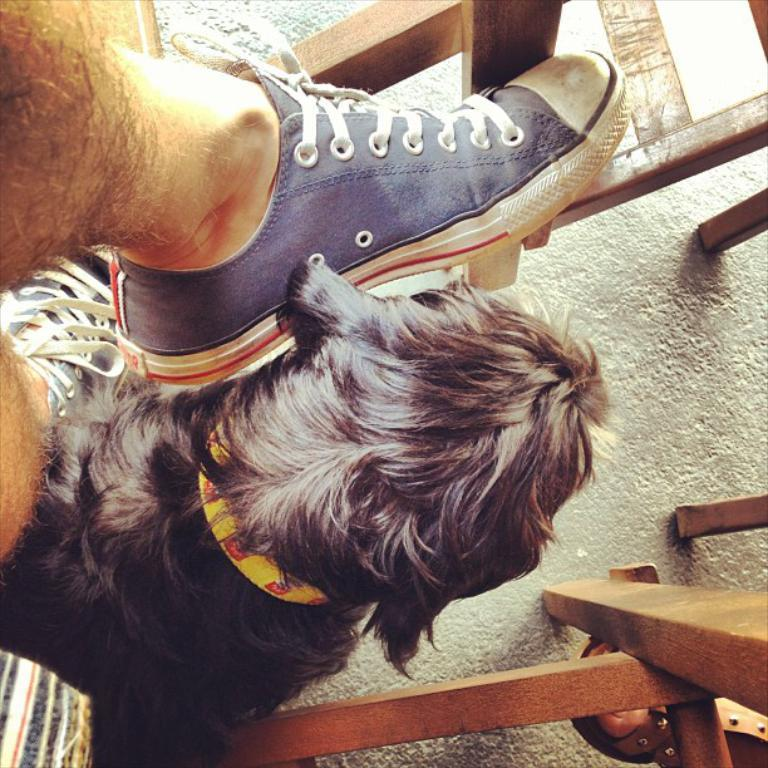What can be seen in the image that belongs to a person? There are legs of persons in the image. What type of living creature is present in the image? There is an animal in the image. What material is used for some objects in the image? There are wooden objects in the image. What type of lettuce is being used as a string to tie the animal's legs in the image? There is no lettuce or string present in the image, and the animal's legs are not tied. 